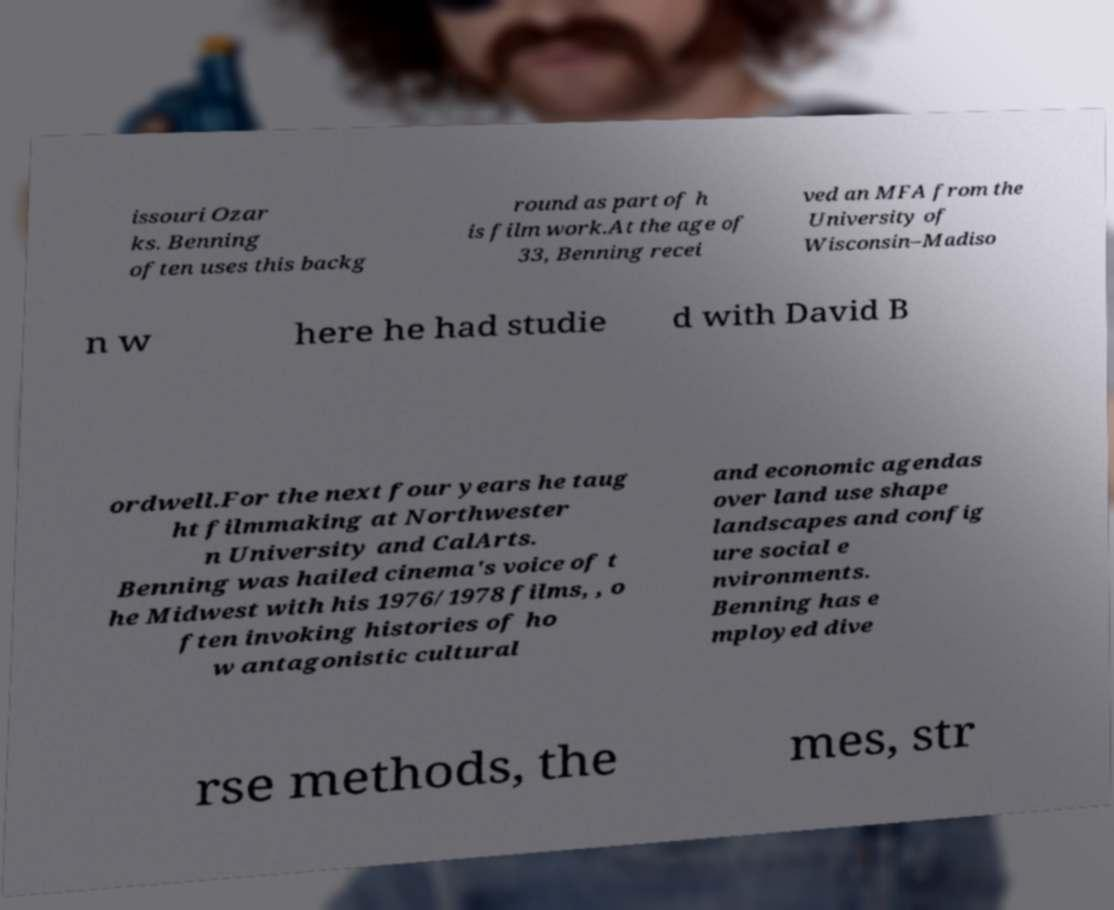Can you accurately transcribe the text from the provided image for me? issouri Ozar ks. Benning often uses this backg round as part of h is film work.At the age of 33, Benning recei ved an MFA from the University of Wisconsin–Madiso n w here he had studie d with David B ordwell.For the next four years he taug ht filmmaking at Northwester n University and CalArts. Benning was hailed cinema's voice of t he Midwest with his 1976/1978 films, , o ften invoking histories of ho w antagonistic cultural and economic agendas over land use shape landscapes and config ure social e nvironments. Benning has e mployed dive rse methods, the mes, str 